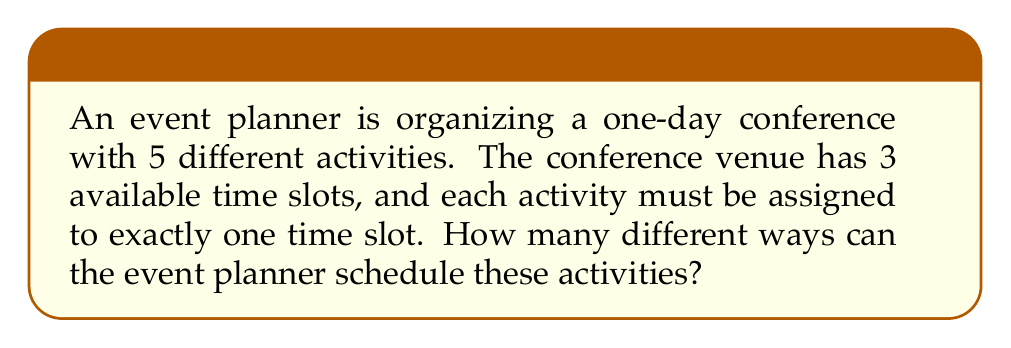Help me with this question. Let's approach this step-by-step:

1) We can think of this as distributing 5 distinct activities into 3 distinct time slots.

2) This is a case of distributing distinct objects into distinct boxes, where some boxes may be empty.

3) For each activity, we have 3 choices (the 3 time slots). Since there are 5 activities, and each activity's placement is independent of the others, we can use the multiplication principle.

4) The total number of ways to schedule the activities is thus:

   $$3 \times 3 \times 3 \times 3 \times 3 = 3^5$$

5) We can calculate this:

   $$3^5 = 3 \times 3 \times 3 \times 3 \times 3 = 243$$

Therefore, there are 243 different ways to schedule the 5 activities across the 3 time slots.
Answer: 243 